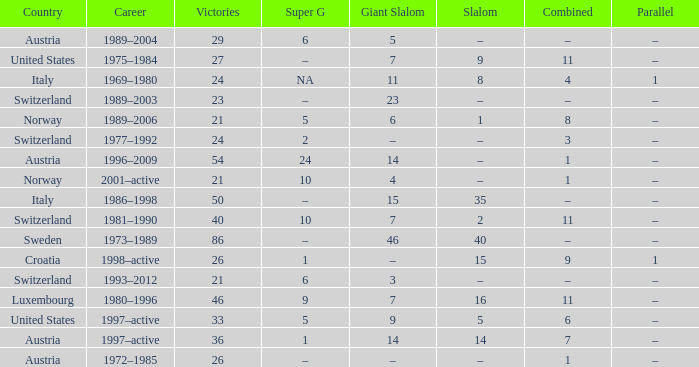What Super G has a Career of 1980–1996? 9.0. 